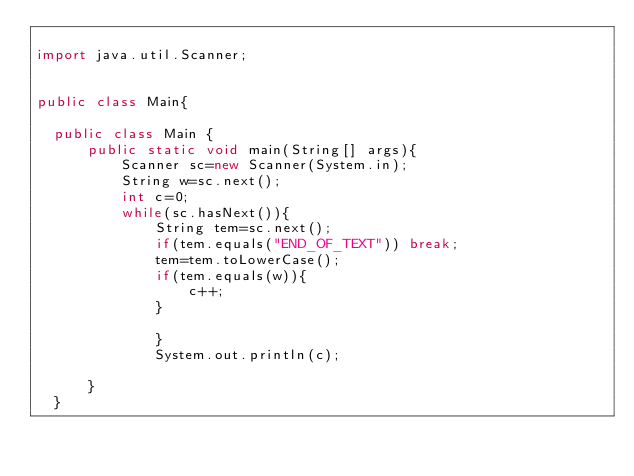Convert code to text. <code><loc_0><loc_0><loc_500><loc_500><_Java_>
import java.util.Scanner;


public class Main{

	public class Main {
	    public static void main(String[] args){
	        Scanner sc=new Scanner(System.in);
	        String w=sc.next();
	        int c=0;
	        while(sc.hasNext()){
	            String tem=sc.next();
	            if(tem.equals("END_OF_TEXT")) break;
	            tem=tem.toLowerCase();
	            if(tem.equals(w)){
	                c++;
	            }

	            }
	            System.out.println(c);

	    }
	}</code> 